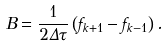<formula> <loc_0><loc_0><loc_500><loc_500>B = \frac { 1 } { 2 \Delta \tau } \left ( f _ { k + 1 } - f _ { k - 1 } \right ) .</formula> 